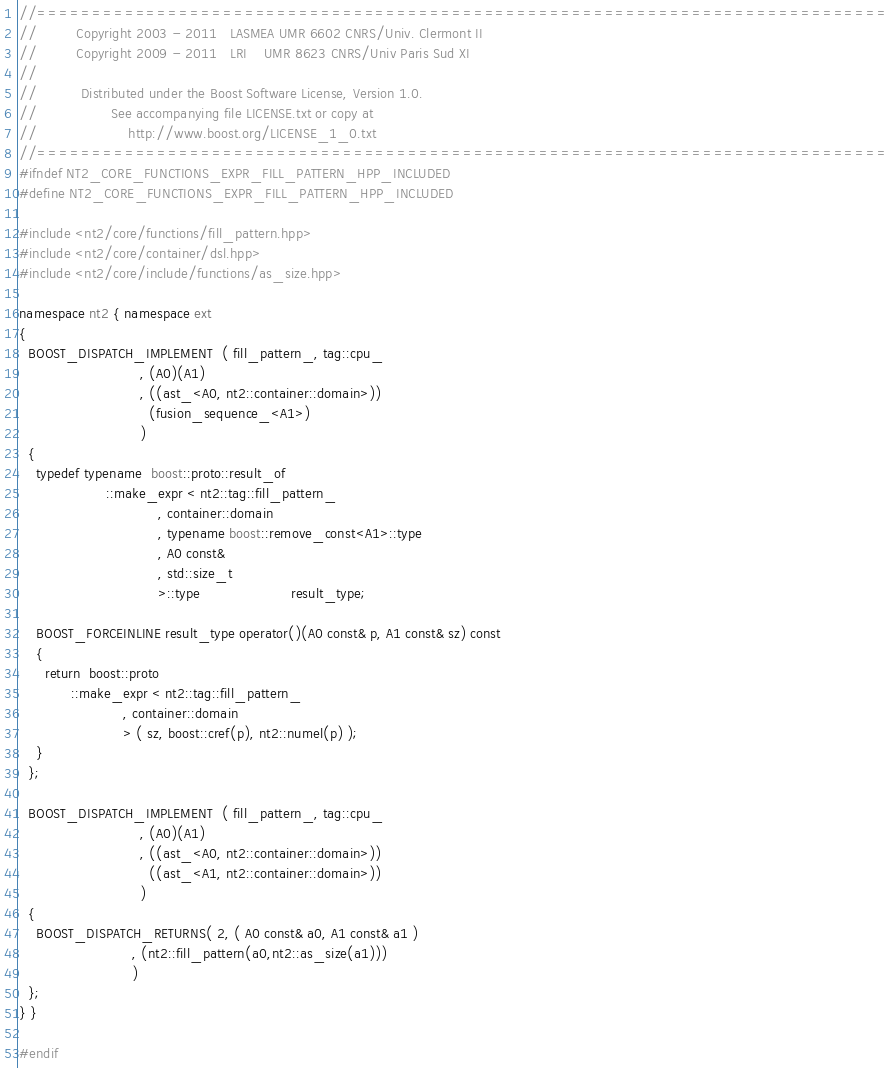<code> <loc_0><loc_0><loc_500><loc_500><_C++_>//==============================================================================
//         Copyright 2003 - 2011   LASMEA UMR 6602 CNRS/Univ. Clermont II
//         Copyright 2009 - 2011   LRI    UMR 8623 CNRS/Univ Paris Sud XI
//
//          Distributed under the Boost Software License, Version 1.0.
//                 See accompanying file LICENSE.txt or copy at
//                     http://www.boost.org/LICENSE_1_0.txt
//==============================================================================
#ifndef NT2_CORE_FUNCTIONS_EXPR_FILL_PATTERN_HPP_INCLUDED
#define NT2_CORE_FUNCTIONS_EXPR_FILL_PATTERN_HPP_INCLUDED

#include <nt2/core/functions/fill_pattern.hpp>
#include <nt2/core/container/dsl.hpp>
#include <nt2/core/include/functions/as_size.hpp>

namespace nt2 { namespace ext
{
  BOOST_DISPATCH_IMPLEMENT  ( fill_pattern_, tag::cpu_
                            , (A0)(A1)
                            , ((ast_<A0, nt2::container::domain>))
                              (fusion_sequence_<A1>)
                            )
  {
    typedef typename  boost::proto::result_of
                    ::make_expr < nt2::tag::fill_pattern_
                                , container::domain
                                , typename boost::remove_const<A1>::type
                                , A0 const&
                                , std::size_t
                                >::type                     result_type;

    BOOST_FORCEINLINE result_type operator()(A0 const& p, A1 const& sz) const
    {
      return  boost::proto
            ::make_expr < nt2::tag::fill_pattern_
                        , container::domain
                        > ( sz, boost::cref(p), nt2::numel(p) );
    }
  };

  BOOST_DISPATCH_IMPLEMENT  ( fill_pattern_, tag::cpu_
                            , (A0)(A1)
                            , ((ast_<A0, nt2::container::domain>))
                              ((ast_<A1, nt2::container::domain>))
                            )
  {
    BOOST_DISPATCH_RETURNS( 2, ( A0 const& a0, A1 const& a1 )
                          , (nt2::fill_pattern(a0,nt2::as_size(a1)))
                          )
  };
} }

#endif
</code> 